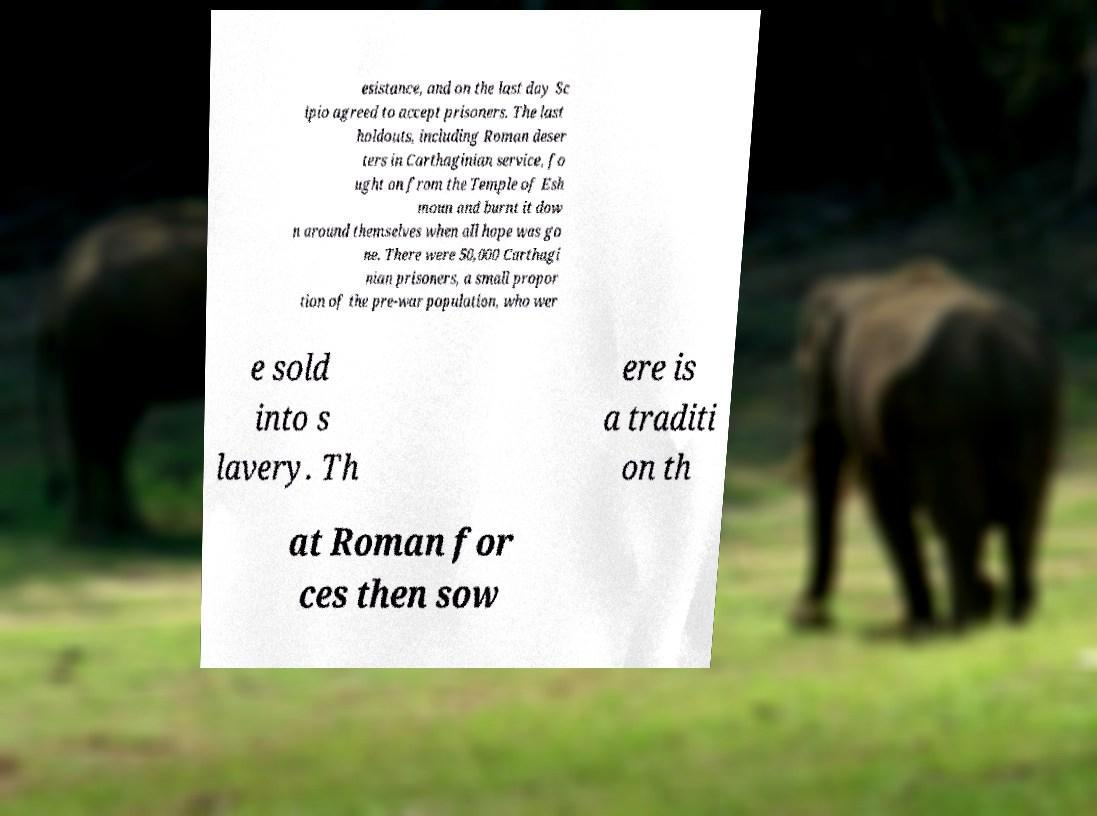There's text embedded in this image that I need extracted. Can you transcribe it verbatim? esistance, and on the last day Sc ipio agreed to accept prisoners. The last holdouts, including Roman deser ters in Carthaginian service, fo ught on from the Temple of Esh moun and burnt it dow n around themselves when all hope was go ne. There were 50,000 Carthagi nian prisoners, a small propor tion of the pre-war population, who wer e sold into s lavery. Th ere is a traditi on th at Roman for ces then sow 